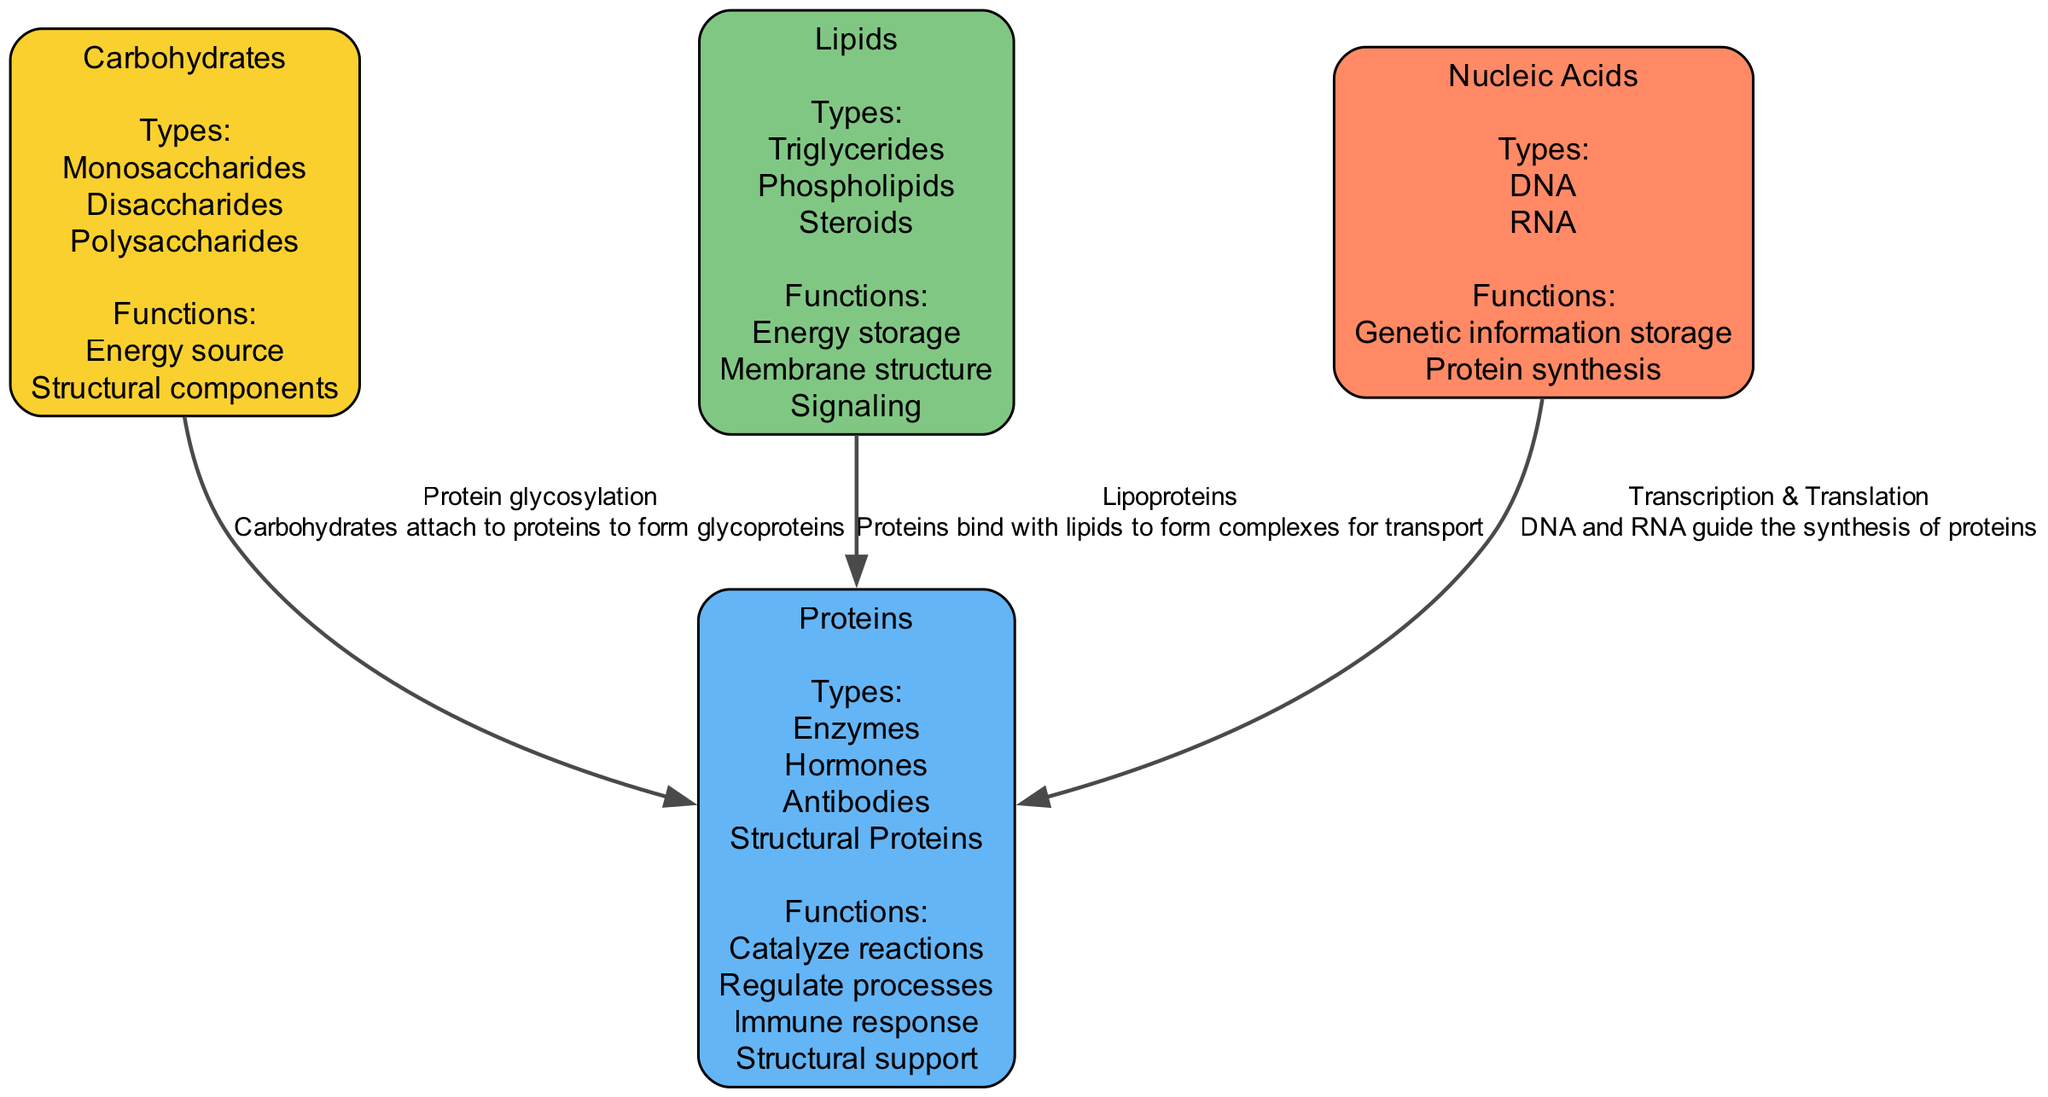What are the types of carbohydrates? The diagram lists the types of carbohydrates under the "Carbohydrates" node. These include Monosaccharides, Disaccharides, and Polysaccharides.
Answer: Monosaccharides, Disaccharides, Polysaccharides How many major biomolecules are represented in the diagram? By counting the nodes in the diagram, we see that there are four major biomolecules: Carbohydrates, Proteins, Lipids, and Nucleic Acids.
Answer: Four What functions do proteins serve according to the diagram? The diagram specifies several functions of proteins listed under the "Proteins" node. They include Catalyze reactions, Regulate processes, Immune response, and Structural support.
Answer: Catalyze reactions, Regulate processes, Immune response, Structural support Which biomolecule is involved in genetic information storage? The diagram shows that Nucleic Acids serve the function of genetic information storage, as listed under the "Nucleic Acids" node.
Answer: Nucleic Acids What is the relationship between carbohydrates and proteins described in the diagram? The diagram describes a specific relationship through the edge labeled "Protein glycosylation," indicating that carbohydrates attach to proteins to form glycoproteins.
Answer: Protein glycosylation How do lipids interact with proteins according to the diagram? The diagram indicates the relationship through the edge labeled "Lipoproteins," explaining that proteins bind with lipids to form complexes for transport.
Answer: Lipoproteins Which biomolecule comprises DNA and RNA? The diagram identifies Nucleic Acids as comprising DNA and RNA, which are detailed under the "Nucleic Acids" node.
Answer: Nucleic Acids What is one function of lipids mentioned in the diagram? The diagram lists the functions of lipids under the "Lipids" node. One of these functions is Energy storage, among others.
Answer: Energy storage Which type of edge connects nucleic acids to proteins? The edge labeled "Transcription & Translation" connects nucleic acids to proteins, illustrating the process where DNA and RNA guide protein synthesis.
Answer: Transcription & Translation 